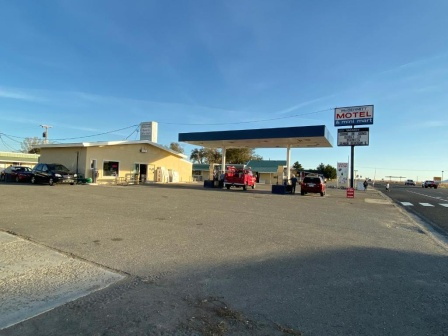What do you think is going on in this snapshot? The image offers a vibrant glimpse into daily life at a roadside ensemble featuring a gas station and motel under an expansive blue sky. A red truck, vivid against the neutral tones of the scene, is parked at the pump, likely refueling. Nearby, other cars hint at the presence of travelers or locals stopping to rest or grab necessities. Prominently, the motel stands as a beacon for road-weary travelers, its classic 'MOTEL' sign in bold red inviting a pause from the journey. Power lines overhead and the clear sky add a touch of vastness to the setting, evoking the breadth of journeys that intersect at this humble yet bustling locale. It’s a snapshot of transient moments and the constant flux of travel. 